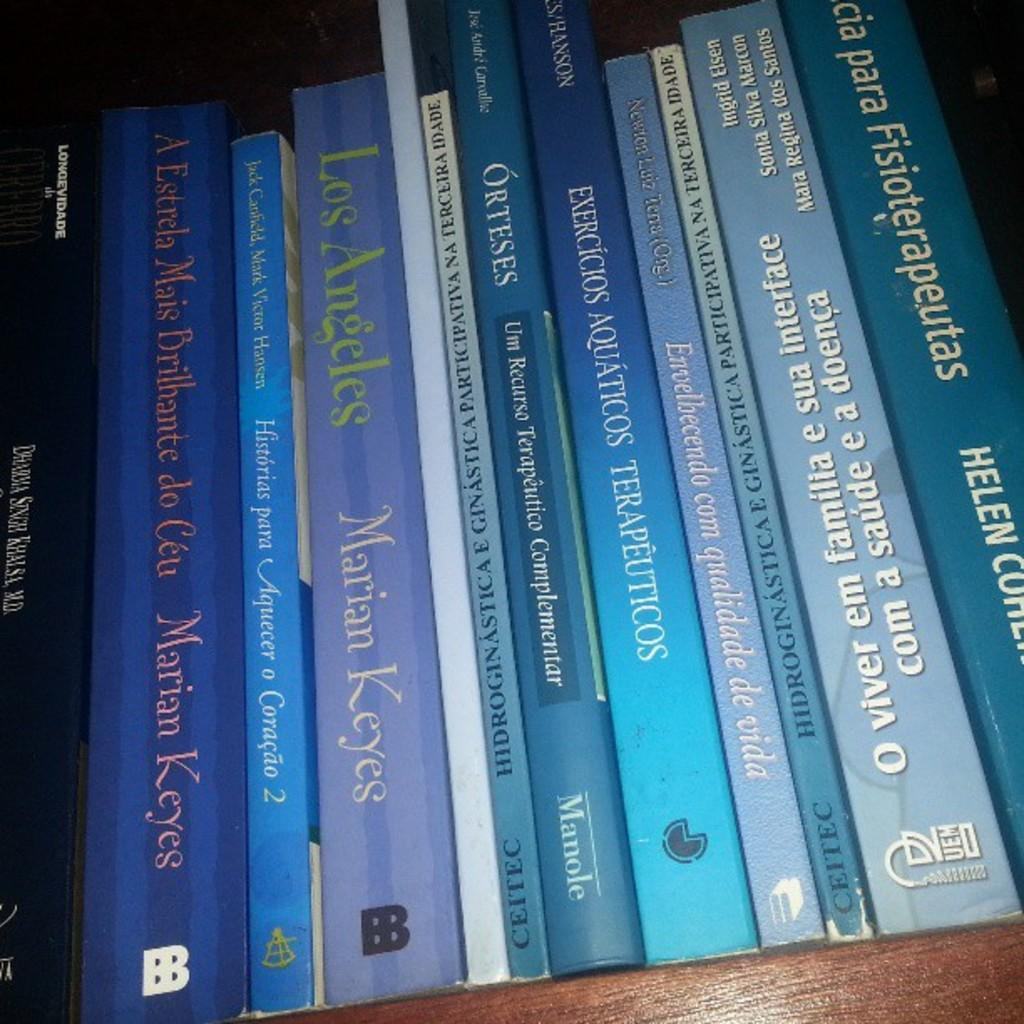<image>
Relay a brief, clear account of the picture shown. A book titled Los Angeles sits on a shelf with other books. 